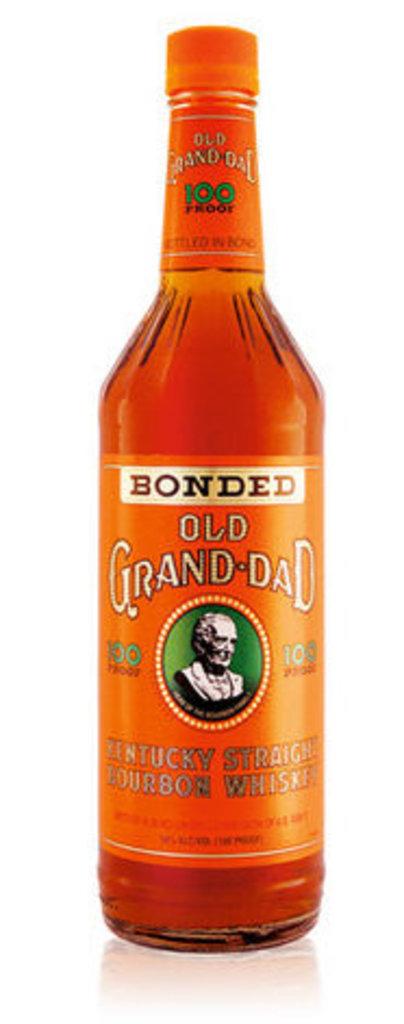What does it say in the white box?
Provide a short and direct response. Bonded. 